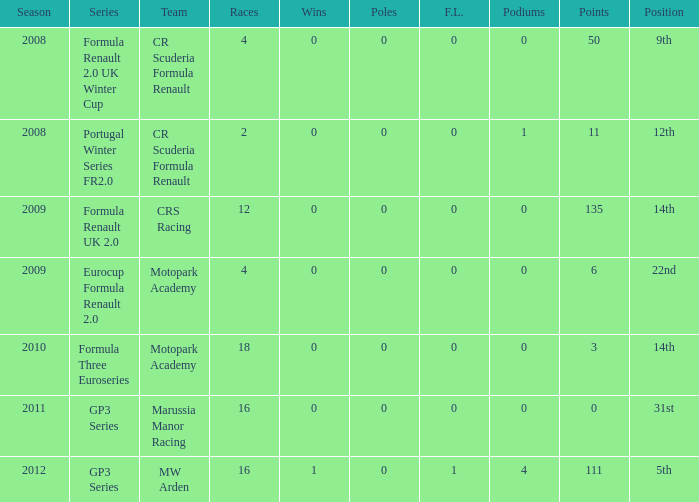What is the number of f.l. mentioned for the formula three euroseries? 1.0. 